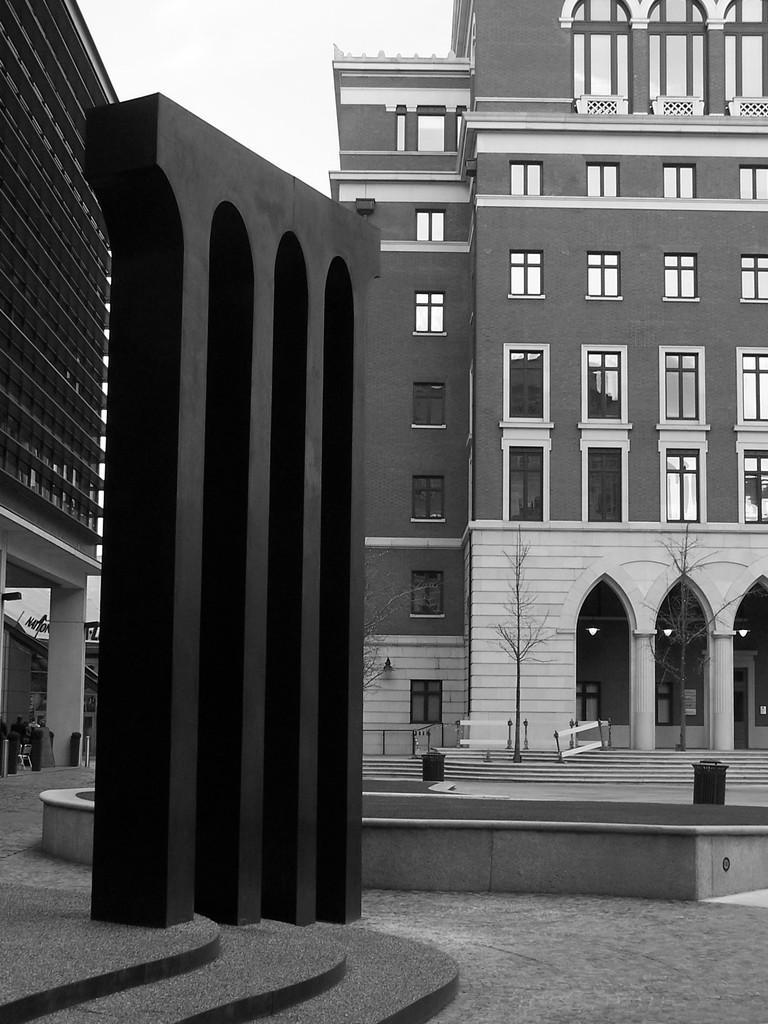Could you give a brief overview of what you see in this image? This picture is clicked outside the city. Here, we see buildings and trees. At the bottom of the picture, we see the staircase and poles. At the top of the picture, we see the sky and this is a black and white picture. 